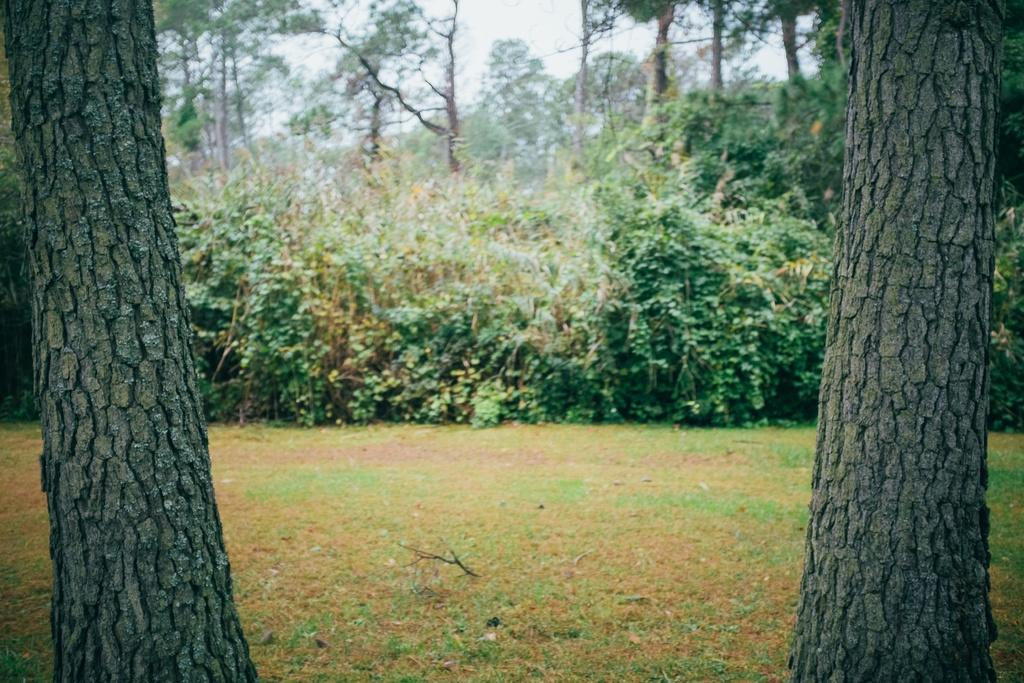What type of vegetation can be seen in the image? There are trees and grass in the image. Can you describe the natural environment depicted in the image? The image features trees and grass, which suggests a natural setting. How many tomatoes are growing on the trees in the image? There are no tomatoes present in the image, as it only features trees and grass. 